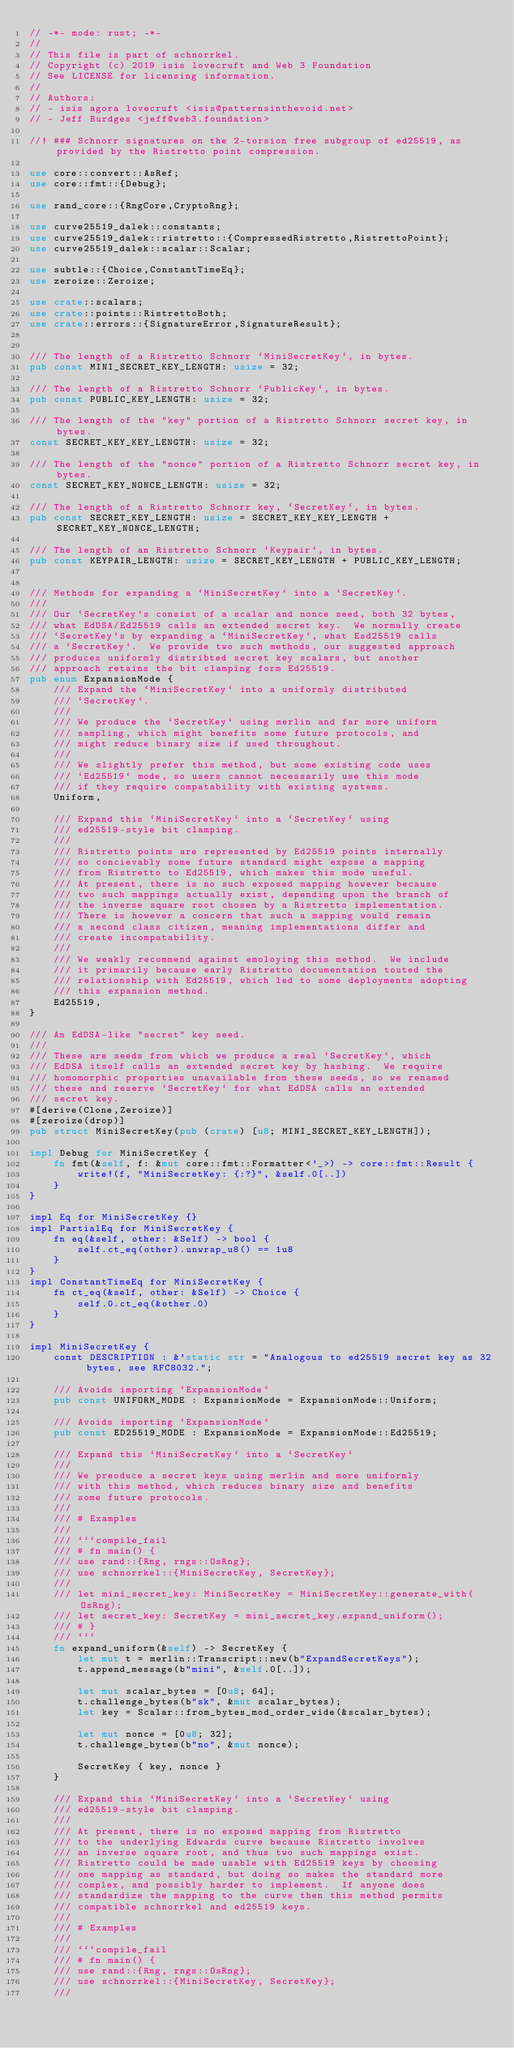Convert code to text. <code><loc_0><loc_0><loc_500><loc_500><_Rust_>// -*- mode: rust; -*-
//
// This file is part of schnorrkel.
// Copyright (c) 2019 isis lovecruft and Web 3 Foundation
// See LICENSE for licensing information.
//
// Authors:
// - isis agora lovecruft <isis@patternsinthevoid.net>
// - Jeff Burdges <jeff@web3.foundation>

//! ### Schnorr signatures on the 2-torsion free subgroup of ed25519, as provided by the Ristretto point compression.

use core::convert::AsRef;
use core::fmt::{Debug};

use rand_core::{RngCore,CryptoRng};

use curve25519_dalek::constants;
use curve25519_dalek::ristretto::{CompressedRistretto,RistrettoPoint};
use curve25519_dalek::scalar::Scalar;

use subtle::{Choice,ConstantTimeEq};
use zeroize::Zeroize;

use crate::scalars;
use crate::points::RistrettoBoth;
use crate::errors::{SignatureError,SignatureResult};


/// The length of a Ristretto Schnorr `MiniSecretKey`, in bytes.
pub const MINI_SECRET_KEY_LENGTH: usize = 32;

/// The length of a Ristretto Schnorr `PublicKey`, in bytes.
pub const PUBLIC_KEY_LENGTH: usize = 32;

/// The length of the "key" portion of a Ristretto Schnorr secret key, in bytes.
const SECRET_KEY_KEY_LENGTH: usize = 32;

/// The length of the "nonce" portion of a Ristretto Schnorr secret key, in bytes.
const SECRET_KEY_NONCE_LENGTH: usize = 32;

/// The length of a Ristretto Schnorr key, `SecretKey`, in bytes.
pub const SECRET_KEY_LENGTH: usize = SECRET_KEY_KEY_LENGTH + SECRET_KEY_NONCE_LENGTH;

/// The length of an Ristretto Schnorr `Keypair`, in bytes.
pub const KEYPAIR_LENGTH: usize = SECRET_KEY_LENGTH + PUBLIC_KEY_LENGTH;


/// Methods for expanding a `MiniSecretKey` into a `SecretKey`.
///
/// Our `SecretKey`s consist of a scalar and nonce seed, both 32 bytes,
/// what EdDSA/Ed25519 calls an extended secret key.  We normally create
/// `SecretKey`s by expanding a `MiniSecretKey`, what Esd25519 calls
/// a `SecretKey`.  We provide two such methods, our suggested approach
/// produces uniformly distribted secret key scalars, but another
/// approach retains the bit clamping form Ed25519.
pub enum ExpansionMode {
    /// Expand the `MiniSecretKey` into a uniformly distributed
    /// `SecretKey`.
    ///
    /// We produce the `SecretKey` using merlin and far more uniform
    /// sampling, which might benefits some future protocols, and
    /// might reduce binary size if used throughout.
    ///
    /// We slightly prefer this method, but some existing code uses
    /// `Ed25519` mode, so users cannot necessarily use this mode
    /// if they require compatability with existing systems.
    Uniform,

    /// Expand this `MiniSecretKey` into a `SecretKey` using
    /// ed25519-style bit clamping.
    ///
    /// Ristretto points are represented by Ed25519 points internally
    /// so concievably some future standard might expose a mapping
    /// from Ristretto to Ed25519, which makes this mode useful.
    /// At present, there is no such exposed mapping however because
    /// two such mappings actually exist, depending upon the branch of
    /// the inverse square root chosen by a Ristretto implementation.
    /// There is however a concern that such a mapping would remain
    /// a second class citizen, meaning implementations differ and
    /// create incompatability.
    ///
    /// We weakly recommend against emoloying this method.  We include
    /// it primarily because early Ristretto documentation touted the
    /// relationship with Ed25519, which led to some deployments adopting
    /// this expansion method.
    Ed25519,
}

/// An EdDSA-like "secret" key seed.
///
/// These are seeds from which we produce a real `SecretKey`, which
/// EdDSA itself calls an extended secret key by hashing.  We require
/// homomorphic properties unavailable from these seeds, so we renamed
/// these and reserve `SecretKey` for what EdDSA calls an extended
/// secret key.
#[derive(Clone,Zeroize)]
#[zeroize(drop)]
pub struct MiniSecretKey(pub (crate) [u8; MINI_SECRET_KEY_LENGTH]);

impl Debug for MiniSecretKey {
    fn fmt(&self, f: &mut core::fmt::Formatter<'_>) -> core::fmt::Result {
        write!(f, "MiniSecretKey: {:?}", &self.0[..])
    }
}

impl Eq for MiniSecretKey {}
impl PartialEq for MiniSecretKey {
    fn eq(&self, other: &Self) -> bool {
        self.ct_eq(other).unwrap_u8() == 1u8
    }
}
impl ConstantTimeEq for MiniSecretKey {
    fn ct_eq(&self, other: &Self) -> Choice {
        self.0.ct_eq(&other.0)
    }
}

impl MiniSecretKey {
    const DESCRIPTION : &'static str = "Analogous to ed25519 secret key as 32 bytes, see RFC8032.";

    /// Avoids importing `ExpansionMode`
    pub const UNIFORM_MODE : ExpansionMode = ExpansionMode::Uniform;

    /// Avoids importing `ExpansionMode`
    pub const ED25519_MODE : ExpansionMode = ExpansionMode::Ed25519;

    /// Expand this `MiniSecretKey` into a `SecretKey`
    ///
    /// We preoduce a secret keys using merlin and more uniformly
    /// with this method, which reduces binary size and benefits
    /// some future protocols.
    ///
    /// # Examples
    ///
    /// ```compile_fail
    /// # fn main() {
    /// use rand::{Rng, rngs::OsRng};
    /// use schnorrkel::{MiniSecretKey, SecretKey};
    ///
    /// let mini_secret_key: MiniSecretKey = MiniSecretKey::generate_with(OsRng);
    /// let secret_key: SecretKey = mini_secret_key.expand_uniform();
    /// # }
    /// ```
    fn expand_uniform(&self) -> SecretKey {
        let mut t = merlin::Transcript::new(b"ExpandSecretKeys");
        t.append_message(b"mini", &self.0[..]);

        let mut scalar_bytes = [0u8; 64];
        t.challenge_bytes(b"sk", &mut scalar_bytes);
        let key = Scalar::from_bytes_mod_order_wide(&scalar_bytes);

        let mut nonce = [0u8; 32];
        t.challenge_bytes(b"no", &mut nonce);

        SecretKey { key, nonce }
    }

    /// Expand this `MiniSecretKey` into a `SecretKey` using
    /// ed25519-style bit clamping.
    ///
    /// At present, there is no exposed mapping from Ristretto
    /// to the underlying Edwards curve because Ristretto involves
    /// an inverse square root, and thus two such mappings exist.
    /// Ristretto could be made usable with Ed25519 keys by choosing
    /// one mapping as standard, but doing so makes the standard more
    /// complex, and possibly harder to implement.  If anyone does
    /// standardize the mapping to the curve then this method permits
    /// compatible schnorrkel and ed25519 keys.
    ///
    /// # Examples
    ///
    /// ```compile_fail
    /// # fn main() {
    /// use rand::{Rng, rngs::OsRng};
    /// use schnorrkel::{MiniSecretKey, SecretKey};
    ///</code> 